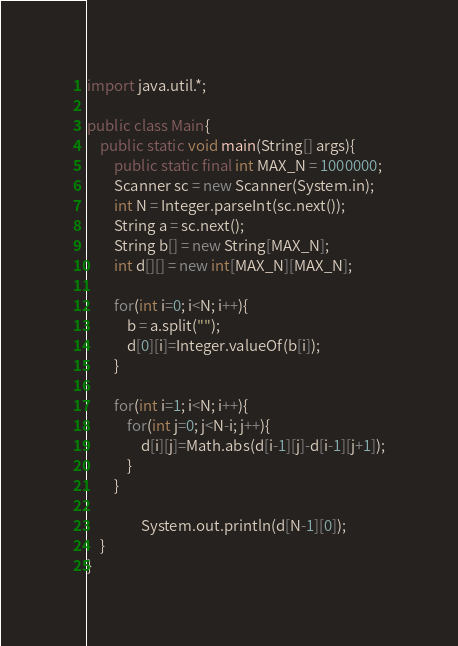<code> <loc_0><loc_0><loc_500><loc_500><_Java_>import java.util.*;
 
public class Main{
    public static void main(String[] args){
		public static final int MAX_N = 1000000;
        Scanner sc = new Scanner(System.in);
		int N = Integer.parseInt(sc.next());
		String a = sc.next();
		String b[] = new String[MAX_N];
		int d[][] = new int[MAX_N][MAX_N];
 
        for(int i=0; i<N; i++){
			b = a.split("");
			d[0][i]=Integer.valueOf(b[i]);
		}
	
		for(int i=1; i<N; i++){
			for(int j=0; j<N-i; j++){
				d[i][j]=Math.abs(d[i-1][j]-d[i-1][j+1]);
			}
		}

                System.out.println(d[N-1][0]);
    }
}</code> 